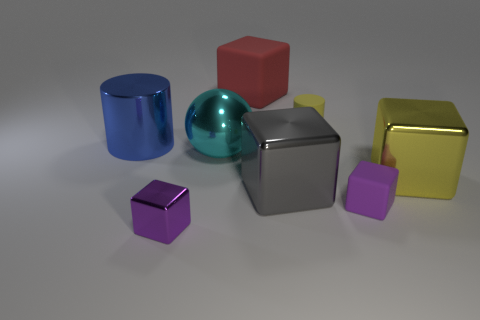Are there any large blue metallic objects right of the cylinder to the right of the tiny purple thing on the left side of the big red matte cube?
Ensure brevity in your answer.  No. There is a big yellow thing that is made of the same material as the ball; what shape is it?
Your response must be concise. Cube. Is the number of yellow metallic things greater than the number of small brown objects?
Provide a succinct answer. Yes. There is a red rubber object; is it the same shape as the big metallic thing that is left of the cyan metal sphere?
Your answer should be compact. No. What material is the large ball?
Your answer should be very brief. Metal. What color is the big object to the right of the tiny block behind the purple block on the left side of the small yellow object?
Offer a very short reply. Yellow. There is a yellow thing that is the same shape as the purple metal object; what is it made of?
Keep it short and to the point. Metal. How many cyan objects have the same size as the blue cylinder?
Offer a very short reply. 1. How many spheres are there?
Ensure brevity in your answer.  1. Does the tiny yellow thing have the same material as the purple cube left of the big rubber thing?
Offer a very short reply. No. 